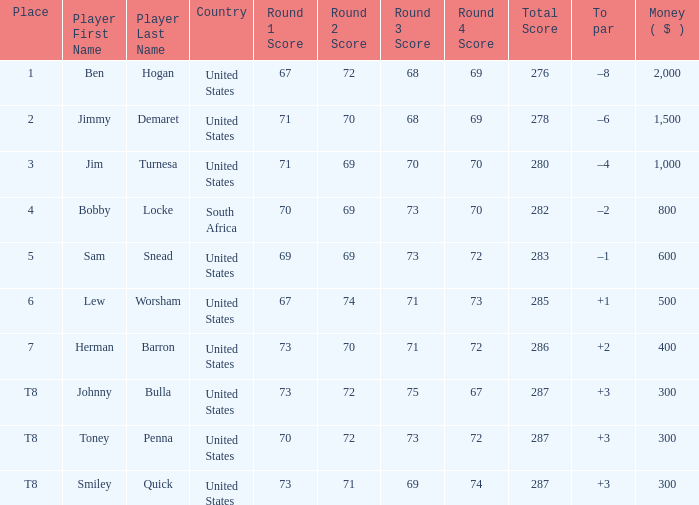What is the To par of the Player with a Score of 73-70-71-72=286? 2.0. 